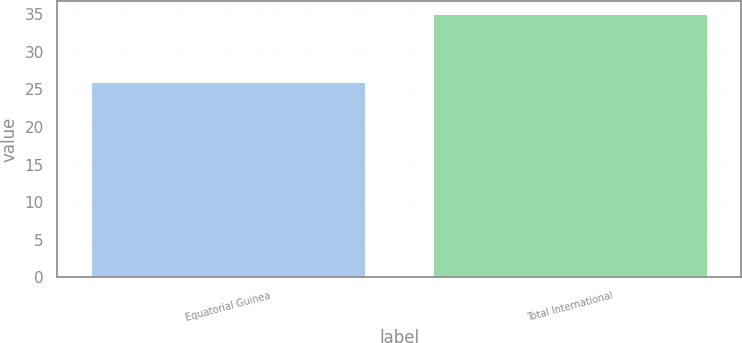Convert chart. <chart><loc_0><loc_0><loc_500><loc_500><bar_chart><fcel>Equatorial Guinea<fcel>Total International<nl><fcel>26<fcel>35<nl></chart> 